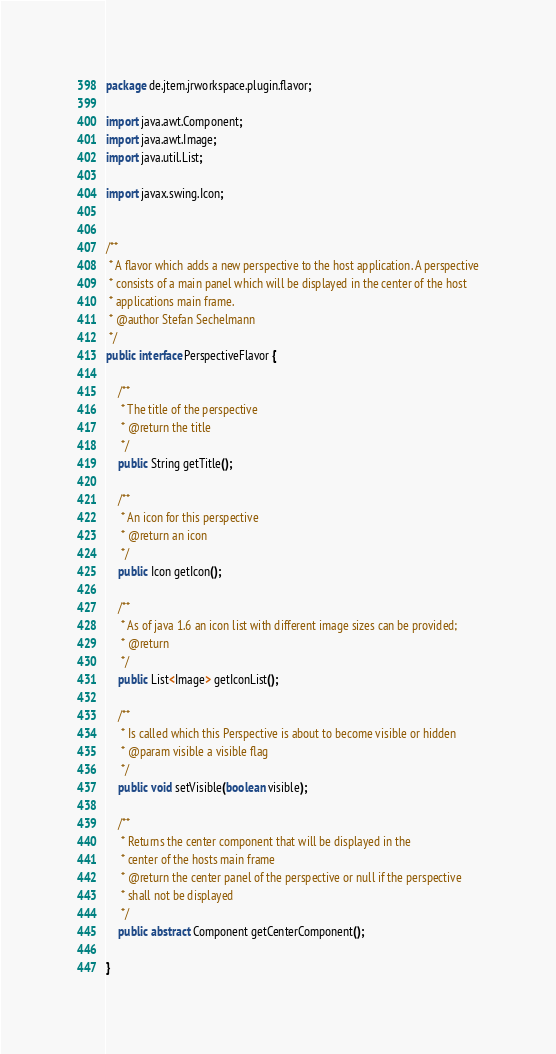Convert code to text. <code><loc_0><loc_0><loc_500><loc_500><_Java_>
package de.jtem.jrworkspace.plugin.flavor;

import java.awt.Component;
import java.awt.Image;
import java.util.List;

import javax.swing.Icon;


/**
 * A flavor which adds a new perspective to the host application. A perspective
 * consists of a main panel which will be displayed in the center of the host
 * applications main frame.
 * @author Stefan Sechelmann
 */
public interface PerspectiveFlavor {

	/**
	 * The title of the perspective
	 * @return the title
	 */
	public String getTitle();
	
	/**
	 * An icon for this perspective
	 * @return an icon
	 */
	public Icon getIcon();
	
	/**
	 * As of java 1.6 an icon list with different image sizes can be provided; 
	 * @return
	 */
	public List<Image> getIconList();
	
	/**
	 * Is called which this Perspective is about to become visible or hidden
	 * @param visible a visible flag
	 */
	public void setVisible(boolean visible);
	
	/**
	 * Returns the center component that will be displayed in the
	 * center of the hosts main frame
	 * @return the center panel of the perspective or null if the perspective
	 * shall not be displayed
	 */
	public abstract Component getCenterComponent();
	
}
</code> 